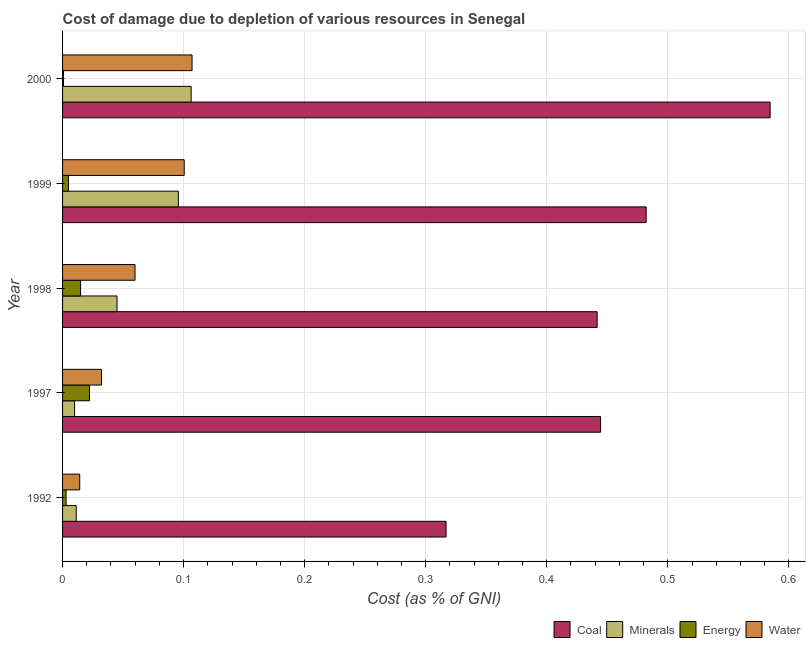How many groups of bars are there?
Make the answer very short. 5. Are the number of bars per tick equal to the number of legend labels?
Make the answer very short. Yes. Are the number of bars on each tick of the Y-axis equal?
Make the answer very short. Yes. How many bars are there on the 4th tick from the top?
Your response must be concise. 4. What is the label of the 1st group of bars from the top?
Ensure brevity in your answer.  2000. What is the cost of damage due to depletion of water in 2000?
Keep it short and to the point. 0.11. Across all years, what is the maximum cost of damage due to depletion of coal?
Make the answer very short. 0.58. Across all years, what is the minimum cost of damage due to depletion of water?
Your answer should be very brief. 0.01. What is the total cost of damage due to depletion of energy in the graph?
Offer a very short reply. 0.05. What is the difference between the cost of damage due to depletion of minerals in 1997 and that in 2000?
Offer a very short reply. -0.1. What is the difference between the cost of damage due to depletion of coal in 1992 and the cost of damage due to depletion of energy in 1999?
Keep it short and to the point. 0.31. What is the average cost of damage due to depletion of coal per year?
Your answer should be compact. 0.45. In the year 1997, what is the difference between the cost of damage due to depletion of minerals and cost of damage due to depletion of water?
Ensure brevity in your answer.  -0.02. What is the ratio of the cost of damage due to depletion of minerals in 1997 to that in 1999?
Your answer should be very brief. 0.1. Is the cost of damage due to depletion of coal in 1992 less than that in 1999?
Ensure brevity in your answer.  Yes. Is the difference between the cost of damage due to depletion of water in 1992 and 2000 greater than the difference between the cost of damage due to depletion of minerals in 1992 and 2000?
Provide a succinct answer. Yes. What is the difference between the highest and the second highest cost of damage due to depletion of water?
Offer a terse response. 0.01. What is the difference between the highest and the lowest cost of damage due to depletion of water?
Provide a short and direct response. 0.09. In how many years, is the cost of damage due to depletion of energy greater than the average cost of damage due to depletion of energy taken over all years?
Your answer should be compact. 2. What does the 3rd bar from the top in 1992 represents?
Provide a short and direct response. Minerals. What does the 4th bar from the bottom in 1998 represents?
Offer a very short reply. Water. Is it the case that in every year, the sum of the cost of damage due to depletion of coal and cost of damage due to depletion of minerals is greater than the cost of damage due to depletion of energy?
Your answer should be compact. Yes. How many bars are there?
Provide a succinct answer. 20. Are all the bars in the graph horizontal?
Provide a short and direct response. Yes. How many years are there in the graph?
Your response must be concise. 5. What is the difference between two consecutive major ticks on the X-axis?
Provide a short and direct response. 0.1. Does the graph contain grids?
Your answer should be compact. Yes. What is the title of the graph?
Provide a short and direct response. Cost of damage due to depletion of various resources in Senegal . Does "Luxembourg" appear as one of the legend labels in the graph?
Ensure brevity in your answer.  No. What is the label or title of the X-axis?
Make the answer very short. Cost (as % of GNI). What is the label or title of the Y-axis?
Offer a very short reply. Year. What is the Cost (as % of GNI) in Coal in 1992?
Give a very brief answer. 0.32. What is the Cost (as % of GNI) in Minerals in 1992?
Ensure brevity in your answer.  0.01. What is the Cost (as % of GNI) of Energy in 1992?
Your answer should be very brief. 0. What is the Cost (as % of GNI) in Water in 1992?
Give a very brief answer. 0.01. What is the Cost (as % of GNI) of Coal in 1997?
Provide a succinct answer. 0.44. What is the Cost (as % of GNI) of Minerals in 1997?
Provide a short and direct response. 0.01. What is the Cost (as % of GNI) in Energy in 1997?
Make the answer very short. 0.02. What is the Cost (as % of GNI) of Water in 1997?
Provide a succinct answer. 0.03. What is the Cost (as % of GNI) in Coal in 1998?
Provide a short and direct response. 0.44. What is the Cost (as % of GNI) of Minerals in 1998?
Keep it short and to the point. 0.04. What is the Cost (as % of GNI) of Energy in 1998?
Make the answer very short. 0.01. What is the Cost (as % of GNI) in Water in 1998?
Offer a terse response. 0.06. What is the Cost (as % of GNI) in Coal in 1999?
Ensure brevity in your answer.  0.48. What is the Cost (as % of GNI) of Minerals in 1999?
Make the answer very short. 0.1. What is the Cost (as % of GNI) of Energy in 1999?
Keep it short and to the point. 0. What is the Cost (as % of GNI) of Water in 1999?
Your response must be concise. 0.1. What is the Cost (as % of GNI) of Coal in 2000?
Provide a short and direct response. 0.58. What is the Cost (as % of GNI) of Minerals in 2000?
Ensure brevity in your answer.  0.11. What is the Cost (as % of GNI) of Energy in 2000?
Provide a succinct answer. 0. What is the Cost (as % of GNI) in Water in 2000?
Give a very brief answer. 0.11. Across all years, what is the maximum Cost (as % of GNI) in Coal?
Offer a very short reply. 0.58. Across all years, what is the maximum Cost (as % of GNI) in Minerals?
Make the answer very short. 0.11. Across all years, what is the maximum Cost (as % of GNI) of Energy?
Offer a very short reply. 0.02. Across all years, what is the maximum Cost (as % of GNI) in Water?
Make the answer very short. 0.11. Across all years, what is the minimum Cost (as % of GNI) of Coal?
Your answer should be compact. 0.32. Across all years, what is the minimum Cost (as % of GNI) in Minerals?
Make the answer very short. 0.01. Across all years, what is the minimum Cost (as % of GNI) in Energy?
Ensure brevity in your answer.  0. Across all years, what is the minimum Cost (as % of GNI) of Water?
Provide a succinct answer. 0.01. What is the total Cost (as % of GNI) in Coal in the graph?
Ensure brevity in your answer.  2.27. What is the total Cost (as % of GNI) in Minerals in the graph?
Make the answer very short. 0.27. What is the total Cost (as % of GNI) in Energy in the graph?
Your answer should be compact. 0.05. What is the total Cost (as % of GNI) of Water in the graph?
Offer a very short reply. 0.31. What is the difference between the Cost (as % of GNI) in Coal in 1992 and that in 1997?
Provide a succinct answer. -0.13. What is the difference between the Cost (as % of GNI) in Minerals in 1992 and that in 1997?
Give a very brief answer. 0. What is the difference between the Cost (as % of GNI) in Energy in 1992 and that in 1997?
Make the answer very short. -0.02. What is the difference between the Cost (as % of GNI) of Water in 1992 and that in 1997?
Keep it short and to the point. -0.02. What is the difference between the Cost (as % of GNI) in Coal in 1992 and that in 1998?
Your response must be concise. -0.12. What is the difference between the Cost (as % of GNI) of Minerals in 1992 and that in 1998?
Offer a terse response. -0.03. What is the difference between the Cost (as % of GNI) of Energy in 1992 and that in 1998?
Give a very brief answer. -0.01. What is the difference between the Cost (as % of GNI) in Water in 1992 and that in 1998?
Make the answer very short. -0.05. What is the difference between the Cost (as % of GNI) in Coal in 1992 and that in 1999?
Your response must be concise. -0.17. What is the difference between the Cost (as % of GNI) of Minerals in 1992 and that in 1999?
Give a very brief answer. -0.08. What is the difference between the Cost (as % of GNI) in Energy in 1992 and that in 1999?
Your answer should be very brief. -0. What is the difference between the Cost (as % of GNI) in Water in 1992 and that in 1999?
Ensure brevity in your answer.  -0.09. What is the difference between the Cost (as % of GNI) of Coal in 1992 and that in 2000?
Your answer should be compact. -0.27. What is the difference between the Cost (as % of GNI) of Minerals in 1992 and that in 2000?
Ensure brevity in your answer.  -0.09. What is the difference between the Cost (as % of GNI) of Energy in 1992 and that in 2000?
Make the answer very short. 0. What is the difference between the Cost (as % of GNI) of Water in 1992 and that in 2000?
Make the answer very short. -0.09. What is the difference between the Cost (as % of GNI) of Coal in 1997 and that in 1998?
Make the answer very short. 0. What is the difference between the Cost (as % of GNI) in Minerals in 1997 and that in 1998?
Ensure brevity in your answer.  -0.04. What is the difference between the Cost (as % of GNI) of Energy in 1997 and that in 1998?
Provide a short and direct response. 0.01. What is the difference between the Cost (as % of GNI) of Water in 1997 and that in 1998?
Your response must be concise. -0.03. What is the difference between the Cost (as % of GNI) in Coal in 1997 and that in 1999?
Ensure brevity in your answer.  -0.04. What is the difference between the Cost (as % of GNI) of Minerals in 1997 and that in 1999?
Your answer should be compact. -0.09. What is the difference between the Cost (as % of GNI) in Energy in 1997 and that in 1999?
Your answer should be compact. 0.02. What is the difference between the Cost (as % of GNI) in Water in 1997 and that in 1999?
Keep it short and to the point. -0.07. What is the difference between the Cost (as % of GNI) in Coal in 1997 and that in 2000?
Make the answer very short. -0.14. What is the difference between the Cost (as % of GNI) in Minerals in 1997 and that in 2000?
Your response must be concise. -0.1. What is the difference between the Cost (as % of GNI) of Energy in 1997 and that in 2000?
Provide a short and direct response. 0.02. What is the difference between the Cost (as % of GNI) of Water in 1997 and that in 2000?
Offer a very short reply. -0.07. What is the difference between the Cost (as % of GNI) in Coal in 1998 and that in 1999?
Provide a short and direct response. -0.04. What is the difference between the Cost (as % of GNI) of Minerals in 1998 and that in 1999?
Your answer should be compact. -0.05. What is the difference between the Cost (as % of GNI) in Water in 1998 and that in 1999?
Make the answer very short. -0.04. What is the difference between the Cost (as % of GNI) of Coal in 1998 and that in 2000?
Your response must be concise. -0.14. What is the difference between the Cost (as % of GNI) of Minerals in 1998 and that in 2000?
Provide a short and direct response. -0.06. What is the difference between the Cost (as % of GNI) in Energy in 1998 and that in 2000?
Keep it short and to the point. 0.01. What is the difference between the Cost (as % of GNI) in Water in 1998 and that in 2000?
Your answer should be very brief. -0.05. What is the difference between the Cost (as % of GNI) in Coal in 1999 and that in 2000?
Your answer should be compact. -0.1. What is the difference between the Cost (as % of GNI) of Minerals in 1999 and that in 2000?
Your answer should be compact. -0.01. What is the difference between the Cost (as % of GNI) of Energy in 1999 and that in 2000?
Your answer should be very brief. 0. What is the difference between the Cost (as % of GNI) in Water in 1999 and that in 2000?
Keep it short and to the point. -0.01. What is the difference between the Cost (as % of GNI) of Coal in 1992 and the Cost (as % of GNI) of Minerals in 1997?
Give a very brief answer. 0.31. What is the difference between the Cost (as % of GNI) of Coal in 1992 and the Cost (as % of GNI) of Energy in 1997?
Make the answer very short. 0.29. What is the difference between the Cost (as % of GNI) of Coal in 1992 and the Cost (as % of GNI) of Water in 1997?
Your answer should be very brief. 0.28. What is the difference between the Cost (as % of GNI) in Minerals in 1992 and the Cost (as % of GNI) in Energy in 1997?
Offer a very short reply. -0.01. What is the difference between the Cost (as % of GNI) of Minerals in 1992 and the Cost (as % of GNI) of Water in 1997?
Keep it short and to the point. -0.02. What is the difference between the Cost (as % of GNI) in Energy in 1992 and the Cost (as % of GNI) in Water in 1997?
Your response must be concise. -0.03. What is the difference between the Cost (as % of GNI) of Coal in 1992 and the Cost (as % of GNI) of Minerals in 1998?
Offer a very short reply. 0.27. What is the difference between the Cost (as % of GNI) in Coal in 1992 and the Cost (as % of GNI) in Energy in 1998?
Provide a succinct answer. 0.3. What is the difference between the Cost (as % of GNI) in Coal in 1992 and the Cost (as % of GNI) in Water in 1998?
Offer a terse response. 0.26. What is the difference between the Cost (as % of GNI) of Minerals in 1992 and the Cost (as % of GNI) of Energy in 1998?
Your answer should be compact. -0. What is the difference between the Cost (as % of GNI) of Minerals in 1992 and the Cost (as % of GNI) of Water in 1998?
Offer a terse response. -0.05. What is the difference between the Cost (as % of GNI) in Energy in 1992 and the Cost (as % of GNI) in Water in 1998?
Your response must be concise. -0.06. What is the difference between the Cost (as % of GNI) in Coal in 1992 and the Cost (as % of GNI) in Minerals in 1999?
Provide a short and direct response. 0.22. What is the difference between the Cost (as % of GNI) of Coal in 1992 and the Cost (as % of GNI) of Energy in 1999?
Offer a very short reply. 0.31. What is the difference between the Cost (as % of GNI) in Coal in 1992 and the Cost (as % of GNI) in Water in 1999?
Make the answer very short. 0.22. What is the difference between the Cost (as % of GNI) in Minerals in 1992 and the Cost (as % of GNI) in Energy in 1999?
Your answer should be very brief. 0.01. What is the difference between the Cost (as % of GNI) in Minerals in 1992 and the Cost (as % of GNI) in Water in 1999?
Make the answer very short. -0.09. What is the difference between the Cost (as % of GNI) in Energy in 1992 and the Cost (as % of GNI) in Water in 1999?
Offer a very short reply. -0.1. What is the difference between the Cost (as % of GNI) of Coal in 1992 and the Cost (as % of GNI) of Minerals in 2000?
Provide a succinct answer. 0.21. What is the difference between the Cost (as % of GNI) in Coal in 1992 and the Cost (as % of GNI) in Energy in 2000?
Ensure brevity in your answer.  0.32. What is the difference between the Cost (as % of GNI) in Coal in 1992 and the Cost (as % of GNI) in Water in 2000?
Keep it short and to the point. 0.21. What is the difference between the Cost (as % of GNI) of Minerals in 1992 and the Cost (as % of GNI) of Energy in 2000?
Keep it short and to the point. 0.01. What is the difference between the Cost (as % of GNI) of Minerals in 1992 and the Cost (as % of GNI) of Water in 2000?
Your response must be concise. -0.1. What is the difference between the Cost (as % of GNI) in Energy in 1992 and the Cost (as % of GNI) in Water in 2000?
Ensure brevity in your answer.  -0.1. What is the difference between the Cost (as % of GNI) in Coal in 1997 and the Cost (as % of GNI) in Minerals in 1998?
Offer a terse response. 0.4. What is the difference between the Cost (as % of GNI) of Coal in 1997 and the Cost (as % of GNI) of Energy in 1998?
Give a very brief answer. 0.43. What is the difference between the Cost (as % of GNI) in Coal in 1997 and the Cost (as % of GNI) in Water in 1998?
Offer a terse response. 0.38. What is the difference between the Cost (as % of GNI) of Minerals in 1997 and the Cost (as % of GNI) of Energy in 1998?
Give a very brief answer. -0. What is the difference between the Cost (as % of GNI) in Minerals in 1997 and the Cost (as % of GNI) in Water in 1998?
Ensure brevity in your answer.  -0.05. What is the difference between the Cost (as % of GNI) in Energy in 1997 and the Cost (as % of GNI) in Water in 1998?
Offer a terse response. -0.04. What is the difference between the Cost (as % of GNI) of Coal in 1997 and the Cost (as % of GNI) of Minerals in 1999?
Give a very brief answer. 0.35. What is the difference between the Cost (as % of GNI) in Coal in 1997 and the Cost (as % of GNI) in Energy in 1999?
Your answer should be compact. 0.44. What is the difference between the Cost (as % of GNI) in Coal in 1997 and the Cost (as % of GNI) in Water in 1999?
Give a very brief answer. 0.34. What is the difference between the Cost (as % of GNI) of Minerals in 1997 and the Cost (as % of GNI) of Energy in 1999?
Make the answer very short. 0.01. What is the difference between the Cost (as % of GNI) in Minerals in 1997 and the Cost (as % of GNI) in Water in 1999?
Provide a succinct answer. -0.09. What is the difference between the Cost (as % of GNI) of Energy in 1997 and the Cost (as % of GNI) of Water in 1999?
Offer a very short reply. -0.08. What is the difference between the Cost (as % of GNI) of Coal in 1997 and the Cost (as % of GNI) of Minerals in 2000?
Make the answer very short. 0.34. What is the difference between the Cost (as % of GNI) of Coal in 1997 and the Cost (as % of GNI) of Energy in 2000?
Offer a very short reply. 0.44. What is the difference between the Cost (as % of GNI) of Coal in 1997 and the Cost (as % of GNI) of Water in 2000?
Ensure brevity in your answer.  0.34. What is the difference between the Cost (as % of GNI) of Minerals in 1997 and the Cost (as % of GNI) of Energy in 2000?
Keep it short and to the point. 0.01. What is the difference between the Cost (as % of GNI) of Minerals in 1997 and the Cost (as % of GNI) of Water in 2000?
Your answer should be compact. -0.1. What is the difference between the Cost (as % of GNI) in Energy in 1997 and the Cost (as % of GNI) in Water in 2000?
Provide a short and direct response. -0.08. What is the difference between the Cost (as % of GNI) in Coal in 1998 and the Cost (as % of GNI) in Minerals in 1999?
Make the answer very short. 0.35. What is the difference between the Cost (as % of GNI) in Coal in 1998 and the Cost (as % of GNI) in Energy in 1999?
Provide a short and direct response. 0.44. What is the difference between the Cost (as % of GNI) in Coal in 1998 and the Cost (as % of GNI) in Water in 1999?
Ensure brevity in your answer.  0.34. What is the difference between the Cost (as % of GNI) of Minerals in 1998 and the Cost (as % of GNI) of Energy in 1999?
Provide a succinct answer. 0.04. What is the difference between the Cost (as % of GNI) in Minerals in 1998 and the Cost (as % of GNI) in Water in 1999?
Your answer should be compact. -0.06. What is the difference between the Cost (as % of GNI) of Energy in 1998 and the Cost (as % of GNI) of Water in 1999?
Your answer should be very brief. -0.09. What is the difference between the Cost (as % of GNI) of Coal in 1998 and the Cost (as % of GNI) of Minerals in 2000?
Your response must be concise. 0.34. What is the difference between the Cost (as % of GNI) of Coal in 1998 and the Cost (as % of GNI) of Energy in 2000?
Offer a very short reply. 0.44. What is the difference between the Cost (as % of GNI) in Coal in 1998 and the Cost (as % of GNI) in Water in 2000?
Provide a short and direct response. 0.33. What is the difference between the Cost (as % of GNI) of Minerals in 1998 and the Cost (as % of GNI) of Energy in 2000?
Provide a short and direct response. 0.04. What is the difference between the Cost (as % of GNI) of Minerals in 1998 and the Cost (as % of GNI) of Water in 2000?
Your response must be concise. -0.06. What is the difference between the Cost (as % of GNI) in Energy in 1998 and the Cost (as % of GNI) in Water in 2000?
Provide a short and direct response. -0.09. What is the difference between the Cost (as % of GNI) in Coal in 1999 and the Cost (as % of GNI) in Minerals in 2000?
Your answer should be very brief. 0.38. What is the difference between the Cost (as % of GNI) in Coal in 1999 and the Cost (as % of GNI) in Energy in 2000?
Your response must be concise. 0.48. What is the difference between the Cost (as % of GNI) of Coal in 1999 and the Cost (as % of GNI) of Water in 2000?
Your response must be concise. 0.38. What is the difference between the Cost (as % of GNI) in Minerals in 1999 and the Cost (as % of GNI) in Energy in 2000?
Make the answer very short. 0.09. What is the difference between the Cost (as % of GNI) of Minerals in 1999 and the Cost (as % of GNI) of Water in 2000?
Keep it short and to the point. -0.01. What is the difference between the Cost (as % of GNI) in Energy in 1999 and the Cost (as % of GNI) in Water in 2000?
Ensure brevity in your answer.  -0.1. What is the average Cost (as % of GNI) in Coal per year?
Offer a very short reply. 0.45. What is the average Cost (as % of GNI) in Minerals per year?
Offer a very short reply. 0.05. What is the average Cost (as % of GNI) of Energy per year?
Keep it short and to the point. 0.01. What is the average Cost (as % of GNI) of Water per year?
Ensure brevity in your answer.  0.06. In the year 1992, what is the difference between the Cost (as % of GNI) in Coal and Cost (as % of GNI) in Minerals?
Your answer should be very brief. 0.31. In the year 1992, what is the difference between the Cost (as % of GNI) in Coal and Cost (as % of GNI) in Energy?
Your answer should be very brief. 0.31. In the year 1992, what is the difference between the Cost (as % of GNI) of Coal and Cost (as % of GNI) of Water?
Keep it short and to the point. 0.3. In the year 1992, what is the difference between the Cost (as % of GNI) in Minerals and Cost (as % of GNI) in Energy?
Make the answer very short. 0.01. In the year 1992, what is the difference between the Cost (as % of GNI) of Minerals and Cost (as % of GNI) of Water?
Make the answer very short. -0. In the year 1992, what is the difference between the Cost (as % of GNI) of Energy and Cost (as % of GNI) of Water?
Offer a terse response. -0.01. In the year 1997, what is the difference between the Cost (as % of GNI) of Coal and Cost (as % of GNI) of Minerals?
Make the answer very short. 0.43. In the year 1997, what is the difference between the Cost (as % of GNI) of Coal and Cost (as % of GNI) of Energy?
Offer a very short reply. 0.42. In the year 1997, what is the difference between the Cost (as % of GNI) of Coal and Cost (as % of GNI) of Water?
Your answer should be compact. 0.41. In the year 1997, what is the difference between the Cost (as % of GNI) in Minerals and Cost (as % of GNI) in Energy?
Give a very brief answer. -0.01. In the year 1997, what is the difference between the Cost (as % of GNI) in Minerals and Cost (as % of GNI) in Water?
Offer a very short reply. -0.02. In the year 1997, what is the difference between the Cost (as % of GNI) in Energy and Cost (as % of GNI) in Water?
Ensure brevity in your answer.  -0.01. In the year 1998, what is the difference between the Cost (as % of GNI) of Coal and Cost (as % of GNI) of Minerals?
Your response must be concise. 0.4. In the year 1998, what is the difference between the Cost (as % of GNI) in Coal and Cost (as % of GNI) in Energy?
Keep it short and to the point. 0.43. In the year 1998, what is the difference between the Cost (as % of GNI) in Coal and Cost (as % of GNI) in Water?
Provide a succinct answer. 0.38. In the year 1998, what is the difference between the Cost (as % of GNI) in Minerals and Cost (as % of GNI) in Energy?
Ensure brevity in your answer.  0.03. In the year 1998, what is the difference between the Cost (as % of GNI) of Minerals and Cost (as % of GNI) of Water?
Your answer should be very brief. -0.01. In the year 1998, what is the difference between the Cost (as % of GNI) in Energy and Cost (as % of GNI) in Water?
Make the answer very short. -0.04. In the year 1999, what is the difference between the Cost (as % of GNI) in Coal and Cost (as % of GNI) in Minerals?
Provide a short and direct response. 0.39. In the year 1999, what is the difference between the Cost (as % of GNI) of Coal and Cost (as % of GNI) of Energy?
Your response must be concise. 0.48. In the year 1999, what is the difference between the Cost (as % of GNI) in Coal and Cost (as % of GNI) in Water?
Ensure brevity in your answer.  0.38. In the year 1999, what is the difference between the Cost (as % of GNI) in Minerals and Cost (as % of GNI) in Energy?
Your answer should be compact. 0.09. In the year 1999, what is the difference between the Cost (as % of GNI) in Minerals and Cost (as % of GNI) in Water?
Your answer should be compact. -0. In the year 1999, what is the difference between the Cost (as % of GNI) in Energy and Cost (as % of GNI) in Water?
Provide a short and direct response. -0.1. In the year 2000, what is the difference between the Cost (as % of GNI) in Coal and Cost (as % of GNI) in Minerals?
Offer a very short reply. 0.48. In the year 2000, what is the difference between the Cost (as % of GNI) in Coal and Cost (as % of GNI) in Energy?
Make the answer very short. 0.58. In the year 2000, what is the difference between the Cost (as % of GNI) in Coal and Cost (as % of GNI) in Water?
Give a very brief answer. 0.48. In the year 2000, what is the difference between the Cost (as % of GNI) of Minerals and Cost (as % of GNI) of Energy?
Your response must be concise. 0.11. In the year 2000, what is the difference between the Cost (as % of GNI) in Minerals and Cost (as % of GNI) in Water?
Offer a terse response. -0. In the year 2000, what is the difference between the Cost (as % of GNI) of Energy and Cost (as % of GNI) of Water?
Keep it short and to the point. -0.11. What is the ratio of the Cost (as % of GNI) in Coal in 1992 to that in 1997?
Offer a terse response. 0.71. What is the ratio of the Cost (as % of GNI) in Minerals in 1992 to that in 1997?
Offer a terse response. 1.14. What is the ratio of the Cost (as % of GNI) of Energy in 1992 to that in 1997?
Offer a very short reply. 0.13. What is the ratio of the Cost (as % of GNI) in Water in 1992 to that in 1997?
Your response must be concise. 0.44. What is the ratio of the Cost (as % of GNI) in Coal in 1992 to that in 1998?
Give a very brief answer. 0.72. What is the ratio of the Cost (as % of GNI) of Minerals in 1992 to that in 1998?
Your response must be concise. 0.25. What is the ratio of the Cost (as % of GNI) in Energy in 1992 to that in 1998?
Ensure brevity in your answer.  0.19. What is the ratio of the Cost (as % of GNI) of Water in 1992 to that in 1998?
Make the answer very short. 0.24. What is the ratio of the Cost (as % of GNI) in Coal in 1992 to that in 1999?
Offer a terse response. 0.66. What is the ratio of the Cost (as % of GNI) in Minerals in 1992 to that in 1999?
Make the answer very short. 0.12. What is the ratio of the Cost (as % of GNI) of Energy in 1992 to that in 1999?
Your response must be concise. 0.6. What is the ratio of the Cost (as % of GNI) in Water in 1992 to that in 1999?
Offer a very short reply. 0.14. What is the ratio of the Cost (as % of GNI) of Coal in 1992 to that in 2000?
Provide a succinct answer. 0.54. What is the ratio of the Cost (as % of GNI) in Minerals in 1992 to that in 2000?
Your answer should be compact. 0.11. What is the ratio of the Cost (as % of GNI) of Energy in 1992 to that in 2000?
Give a very brief answer. 3.79. What is the ratio of the Cost (as % of GNI) in Water in 1992 to that in 2000?
Give a very brief answer. 0.13. What is the ratio of the Cost (as % of GNI) in Coal in 1997 to that in 1998?
Ensure brevity in your answer.  1.01. What is the ratio of the Cost (as % of GNI) in Minerals in 1997 to that in 1998?
Provide a succinct answer. 0.22. What is the ratio of the Cost (as % of GNI) of Energy in 1997 to that in 1998?
Your response must be concise. 1.5. What is the ratio of the Cost (as % of GNI) in Water in 1997 to that in 1998?
Your response must be concise. 0.54. What is the ratio of the Cost (as % of GNI) in Coal in 1997 to that in 1999?
Provide a succinct answer. 0.92. What is the ratio of the Cost (as % of GNI) of Minerals in 1997 to that in 1999?
Your response must be concise. 0.1. What is the ratio of the Cost (as % of GNI) of Energy in 1997 to that in 1999?
Your response must be concise. 4.6. What is the ratio of the Cost (as % of GNI) in Water in 1997 to that in 1999?
Keep it short and to the point. 0.32. What is the ratio of the Cost (as % of GNI) in Coal in 1997 to that in 2000?
Offer a terse response. 0.76. What is the ratio of the Cost (as % of GNI) in Minerals in 1997 to that in 2000?
Offer a terse response. 0.09. What is the ratio of the Cost (as % of GNI) of Energy in 1997 to that in 2000?
Give a very brief answer. 29.09. What is the ratio of the Cost (as % of GNI) of Water in 1997 to that in 2000?
Make the answer very short. 0.3. What is the ratio of the Cost (as % of GNI) in Coal in 1998 to that in 1999?
Offer a terse response. 0.92. What is the ratio of the Cost (as % of GNI) of Minerals in 1998 to that in 1999?
Provide a short and direct response. 0.47. What is the ratio of the Cost (as % of GNI) of Energy in 1998 to that in 1999?
Provide a short and direct response. 3.07. What is the ratio of the Cost (as % of GNI) in Water in 1998 to that in 1999?
Provide a short and direct response. 0.6. What is the ratio of the Cost (as % of GNI) in Coal in 1998 to that in 2000?
Your response must be concise. 0.76. What is the ratio of the Cost (as % of GNI) in Minerals in 1998 to that in 2000?
Provide a succinct answer. 0.42. What is the ratio of the Cost (as % of GNI) of Energy in 1998 to that in 2000?
Your answer should be compact. 19.43. What is the ratio of the Cost (as % of GNI) of Water in 1998 to that in 2000?
Your answer should be very brief. 0.56. What is the ratio of the Cost (as % of GNI) of Coal in 1999 to that in 2000?
Make the answer very short. 0.82. What is the ratio of the Cost (as % of GNI) of Minerals in 1999 to that in 2000?
Your response must be concise. 0.9. What is the ratio of the Cost (as % of GNI) of Energy in 1999 to that in 2000?
Provide a short and direct response. 6.33. What is the ratio of the Cost (as % of GNI) of Water in 1999 to that in 2000?
Provide a succinct answer. 0.94. What is the difference between the highest and the second highest Cost (as % of GNI) of Coal?
Offer a very short reply. 0.1. What is the difference between the highest and the second highest Cost (as % of GNI) in Minerals?
Make the answer very short. 0.01. What is the difference between the highest and the second highest Cost (as % of GNI) of Energy?
Offer a terse response. 0.01. What is the difference between the highest and the second highest Cost (as % of GNI) of Water?
Your answer should be very brief. 0.01. What is the difference between the highest and the lowest Cost (as % of GNI) in Coal?
Keep it short and to the point. 0.27. What is the difference between the highest and the lowest Cost (as % of GNI) in Minerals?
Offer a very short reply. 0.1. What is the difference between the highest and the lowest Cost (as % of GNI) of Energy?
Provide a succinct answer. 0.02. What is the difference between the highest and the lowest Cost (as % of GNI) of Water?
Make the answer very short. 0.09. 